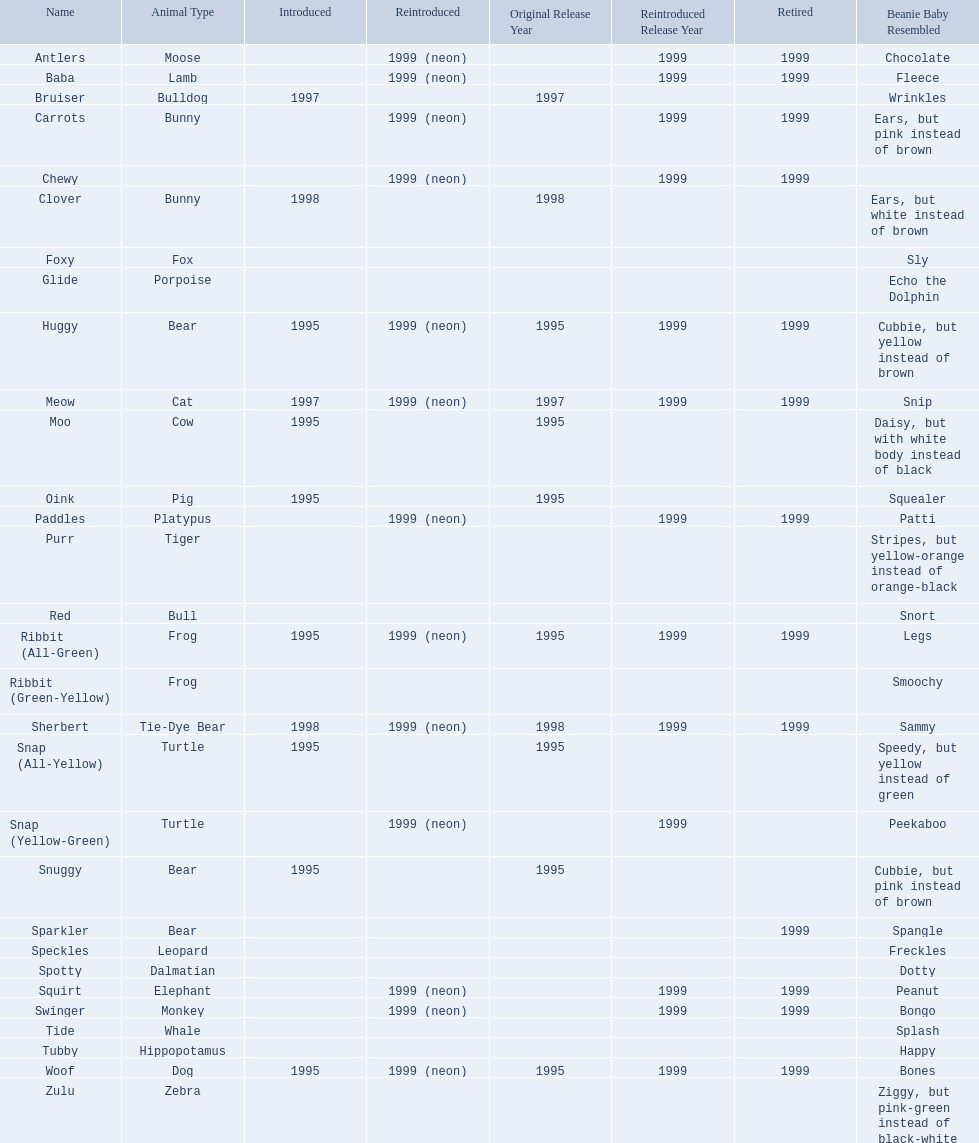What are all the pillow pals? Antlers, Baba, Bruiser, Carrots, Chewy, Clover, Foxy, Glide, Huggy, Meow, Moo, Oink, Paddles, Purr, Red, Ribbit (All-Green), Ribbit (Green-Yellow), Sherbert, Snap (All-Yellow), Snap (Yellow-Green), Snuggy, Sparkler, Speckles, Spotty, Squirt, Swinger, Tide, Tubby, Woof, Zulu. Which is the only without a listed animal type? Chewy. 